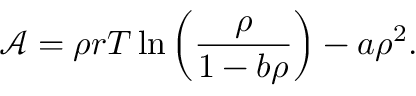Convert formula to latex. <formula><loc_0><loc_0><loc_500><loc_500>\mathcal { A } = \rho r T \ln \left ( \frac { \rho } { 1 - b \rho } \right ) - a \rho ^ { 2 } .</formula> 